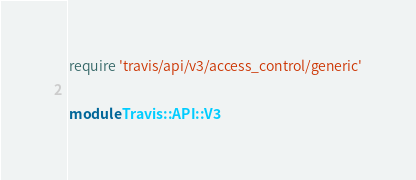<code> <loc_0><loc_0><loc_500><loc_500><_Ruby_>require 'travis/api/v3/access_control/generic'

module Travis::API::V3</code> 